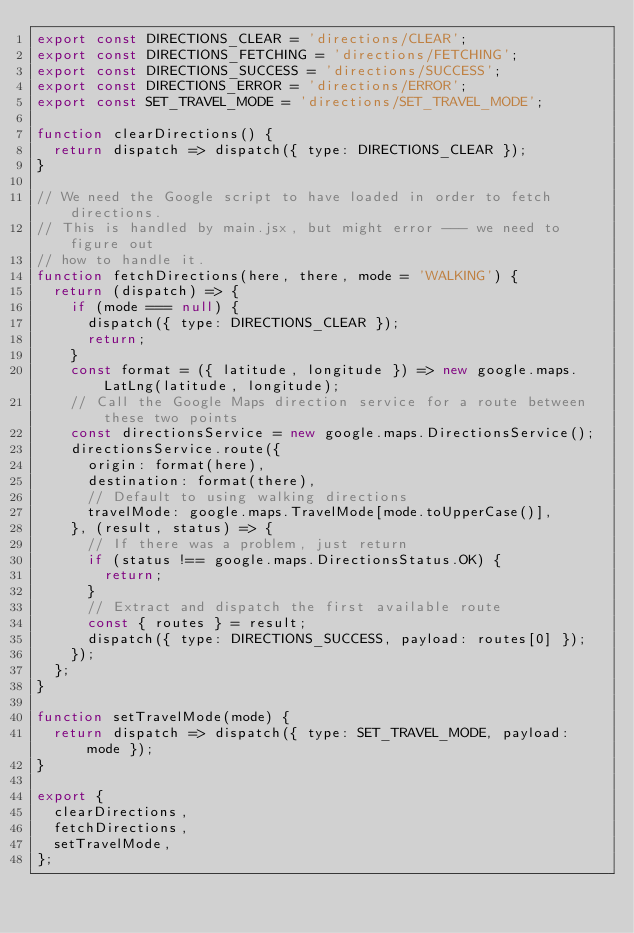Convert code to text. <code><loc_0><loc_0><loc_500><loc_500><_JavaScript_>export const DIRECTIONS_CLEAR = 'directions/CLEAR';
export const DIRECTIONS_FETCHING = 'directions/FETCHING';
export const DIRECTIONS_SUCCESS = 'directions/SUCCESS';
export const DIRECTIONS_ERROR = 'directions/ERROR';
export const SET_TRAVEL_MODE = 'directions/SET_TRAVEL_MODE';

function clearDirections() {
  return dispatch => dispatch({ type: DIRECTIONS_CLEAR });
}

// We need the Google script to have loaded in order to fetch directions.
// This is handled by main.jsx, but might error --- we need to figure out
// how to handle it.
function fetchDirections(here, there, mode = 'WALKING') {
  return (dispatch) => {
    if (mode === null) {
      dispatch({ type: DIRECTIONS_CLEAR });
      return;
    }
    const format = ({ latitude, longitude }) => new google.maps.LatLng(latitude, longitude);
    // Call the Google Maps direction service for a route between these two points
    const directionsService = new google.maps.DirectionsService();
    directionsService.route({
      origin: format(here),
      destination: format(there),
      // Default to using walking directions
      travelMode: google.maps.TravelMode[mode.toUpperCase()],
    }, (result, status) => {
      // If there was a problem, just return
      if (status !== google.maps.DirectionsStatus.OK) {
        return;
      }
      // Extract and dispatch the first available route
      const { routes } = result;
      dispatch({ type: DIRECTIONS_SUCCESS, payload: routes[0] });
    });
  };
}

function setTravelMode(mode) {
  return dispatch => dispatch({ type: SET_TRAVEL_MODE, payload: mode });
}

export {
  clearDirections,
  fetchDirections,
  setTravelMode,
};
</code> 